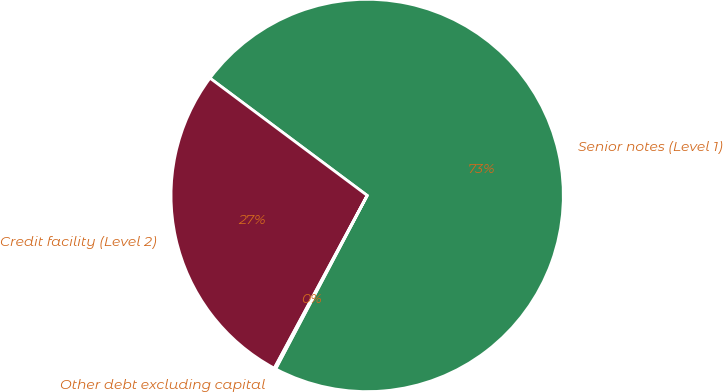Convert chart. <chart><loc_0><loc_0><loc_500><loc_500><pie_chart><fcel>Senior notes (Level 1)<fcel>Credit facility (Level 2)<fcel>Other debt excluding capital<nl><fcel>72.52%<fcel>27.35%<fcel>0.13%<nl></chart> 